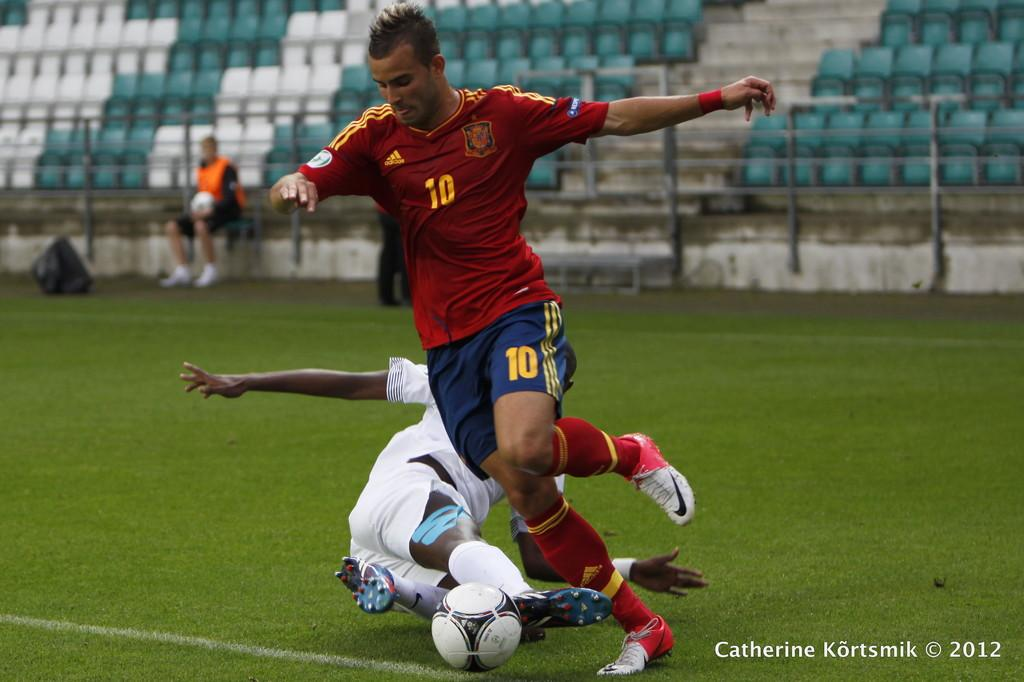<image>
Provide a brief description of the given image. A soccer player number 10 getting ready to kick the ball 